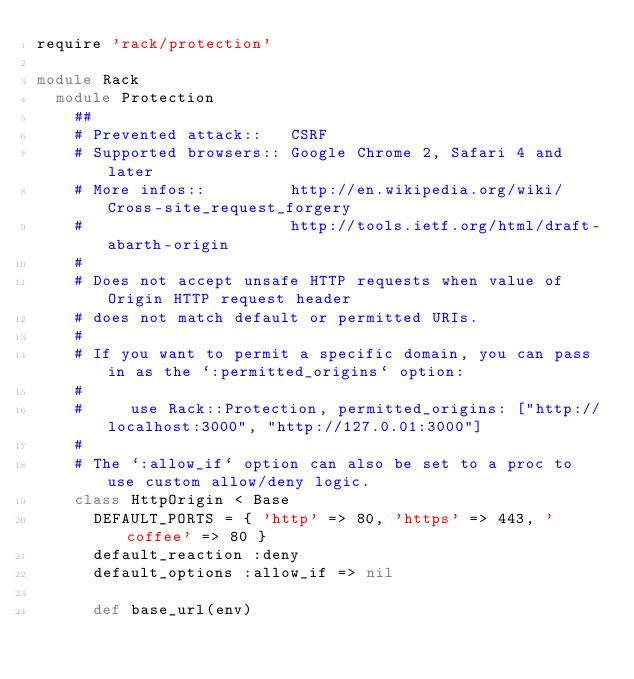<code> <loc_0><loc_0><loc_500><loc_500><_Ruby_>require 'rack/protection'

module Rack
  module Protection
    ##
    # Prevented attack::   CSRF
    # Supported browsers:: Google Chrome 2, Safari 4 and later
    # More infos::         http://en.wikipedia.org/wiki/Cross-site_request_forgery
    #                      http://tools.ietf.org/html/draft-abarth-origin
    #
    # Does not accept unsafe HTTP requests when value of Origin HTTP request header
    # does not match default or permitted URIs.
    #
    # If you want to permit a specific domain, you can pass in as the `:permitted_origins` option:
    #
    #     use Rack::Protection, permitted_origins: ["http://localhost:3000", "http://127.0.01:3000"]
    #
    # The `:allow_if` option can also be set to a proc to use custom allow/deny logic.
    class HttpOrigin < Base
      DEFAULT_PORTS = { 'http' => 80, 'https' => 443, 'coffee' => 80 }
      default_reaction :deny
      default_options :allow_if => nil

      def base_url(env)</code> 